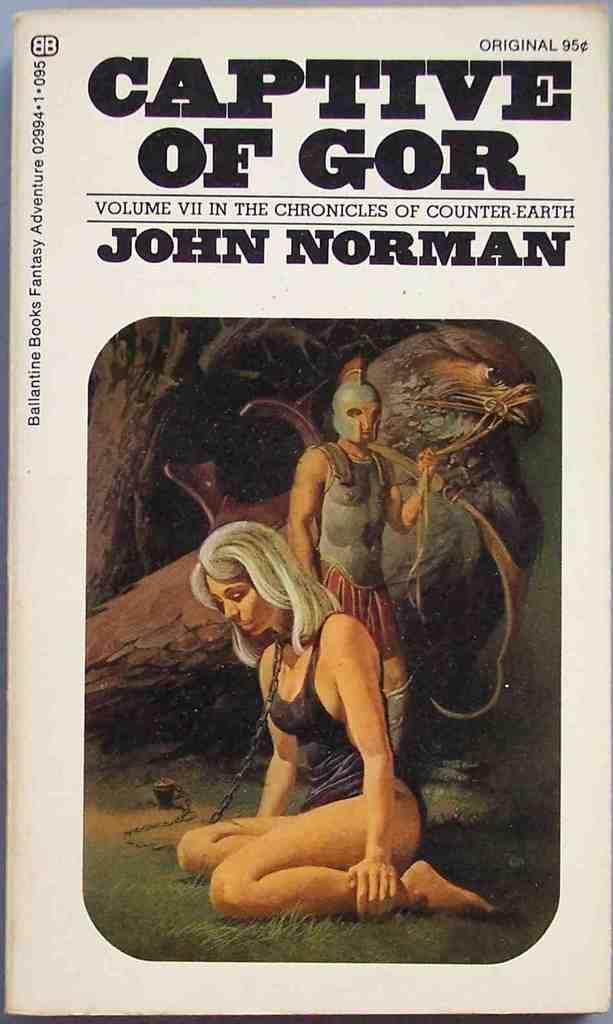What is present in the image that has both pictures and text? There is a paper in the image that has both pictures and text. Can you describe the content of the pictures on the paper? The provided facts do not give information about the content of the pictures on the paper. What type of information might be conveyed by the text on the paper? The text on the paper could convey various types of information, such as instructions, descriptions, or stories. How many tomatoes are visible in the image? There are no tomatoes present in the image. What type of animals can be seen at the zoo in the image? There is no zoo or animals present in the image. 